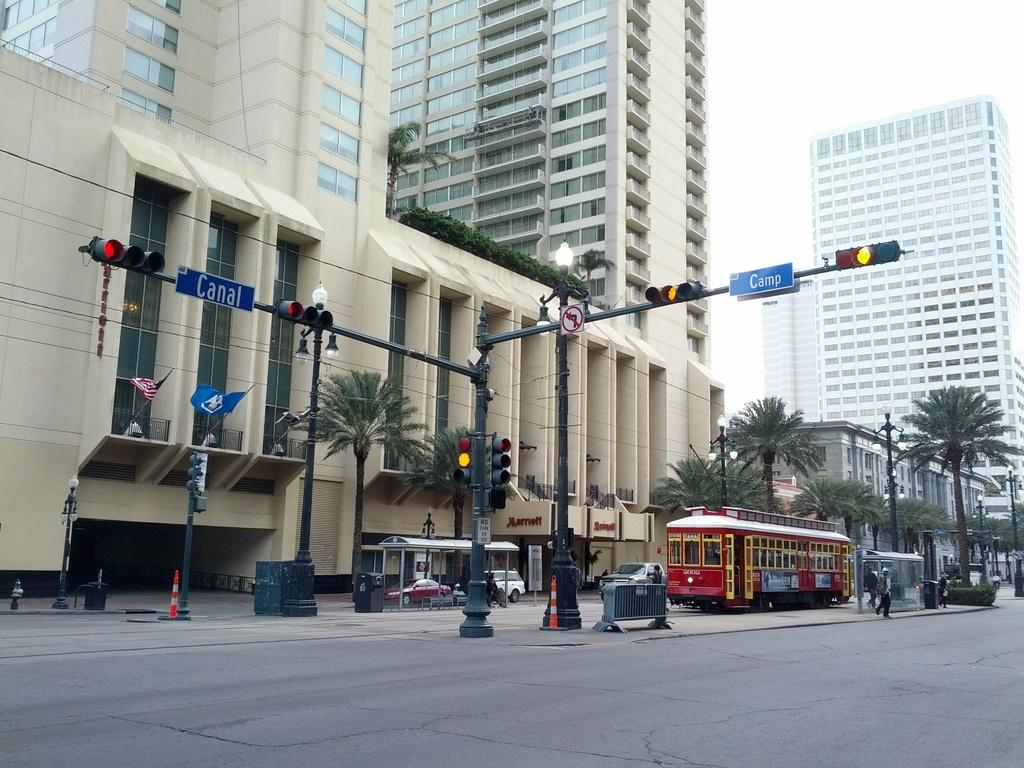<image>
Describe the image concisely. The intersection of Camp and Canal has a red trolley and tall buildings surroundng it 